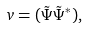Convert formula to latex. <formula><loc_0><loc_0><loc_500><loc_500>v = ( \tilde { \Psi } \tilde { \Psi } ^ { * } ) ,</formula> 